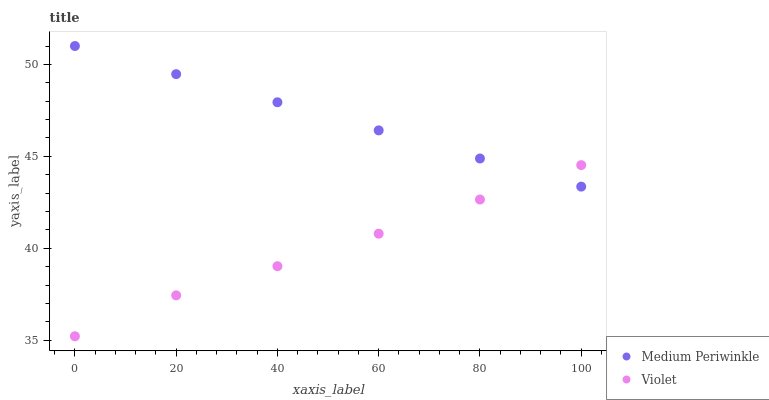Does Violet have the minimum area under the curve?
Answer yes or no. Yes. Does Medium Periwinkle have the maximum area under the curve?
Answer yes or no. Yes. Does Violet have the maximum area under the curve?
Answer yes or no. No. Is Medium Periwinkle the smoothest?
Answer yes or no. Yes. Is Violet the roughest?
Answer yes or no. Yes. Is Violet the smoothest?
Answer yes or no. No. Does Violet have the lowest value?
Answer yes or no. Yes. Does Medium Periwinkle have the highest value?
Answer yes or no. Yes. Does Violet have the highest value?
Answer yes or no. No. Does Medium Periwinkle intersect Violet?
Answer yes or no. Yes. Is Medium Periwinkle less than Violet?
Answer yes or no. No. Is Medium Periwinkle greater than Violet?
Answer yes or no. No. 